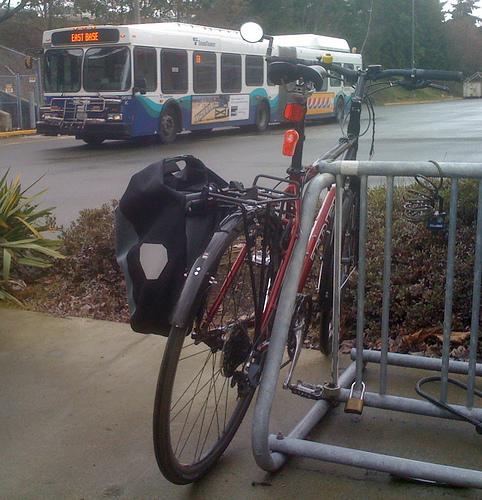What vehicle is this?
Concise answer only. Bicycle. Is there a bus on the street?
Concise answer only. Yes. What is the bike on?
Keep it brief. Rack. 